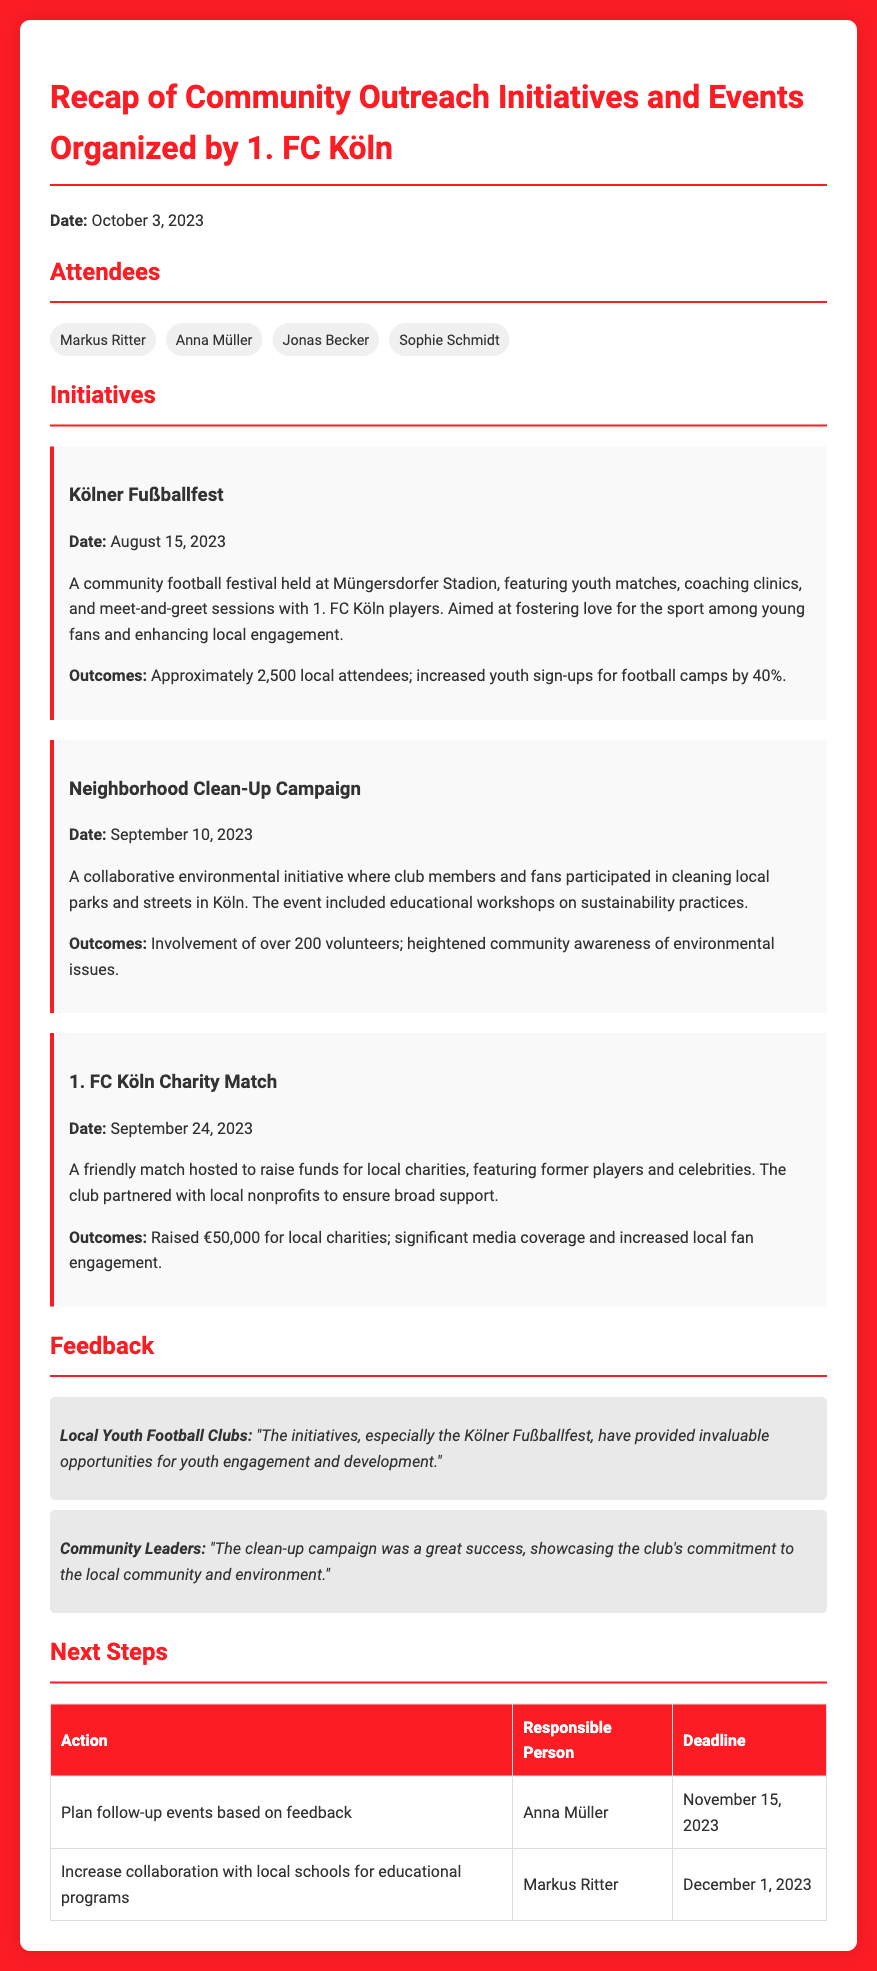what is the date of the Kölner Fußballfest? The Kölner Fußballfest is held on August 15, 2023.
Answer: August 15, 2023 how many local attendees were at the Kölner Fußballfest? The document states that approximately 2,500 local attendees were present at the event.
Answer: 2,500 who is responsible for planning follow-up events? According to the next steps section, Anna Müller is responsible for planning follow-up events.
Answer: Anna Müller what was raised during the 1. FC Köln Charity Match? The document mentions that €50,000 was raised for local charities during the charity match.
Answer: €50,000 how many volunteers participated in the Neighborhood Clean-Up Campaign? Over 200 volunteers participated in the Neighborhood Clean-Up Campaign.
Answer: Over 200 what feedback did local youth football clubs provide? Local youth football clubs stated that the initiatives provided invaluable opportunities for youth engagement and development.
Answer: Invaluable opportunities what are the next steps outlined in the document? The document specifies the planning of follow-up events and increasing collaboration with local schools as the next steps.
Answer: Plan follow-up events, increase collaboration when is the deadline to increase collaboration with local schools? The deadline to increase collaboration with local schools is December 1, 2023.
Answer: December 1, 2023 